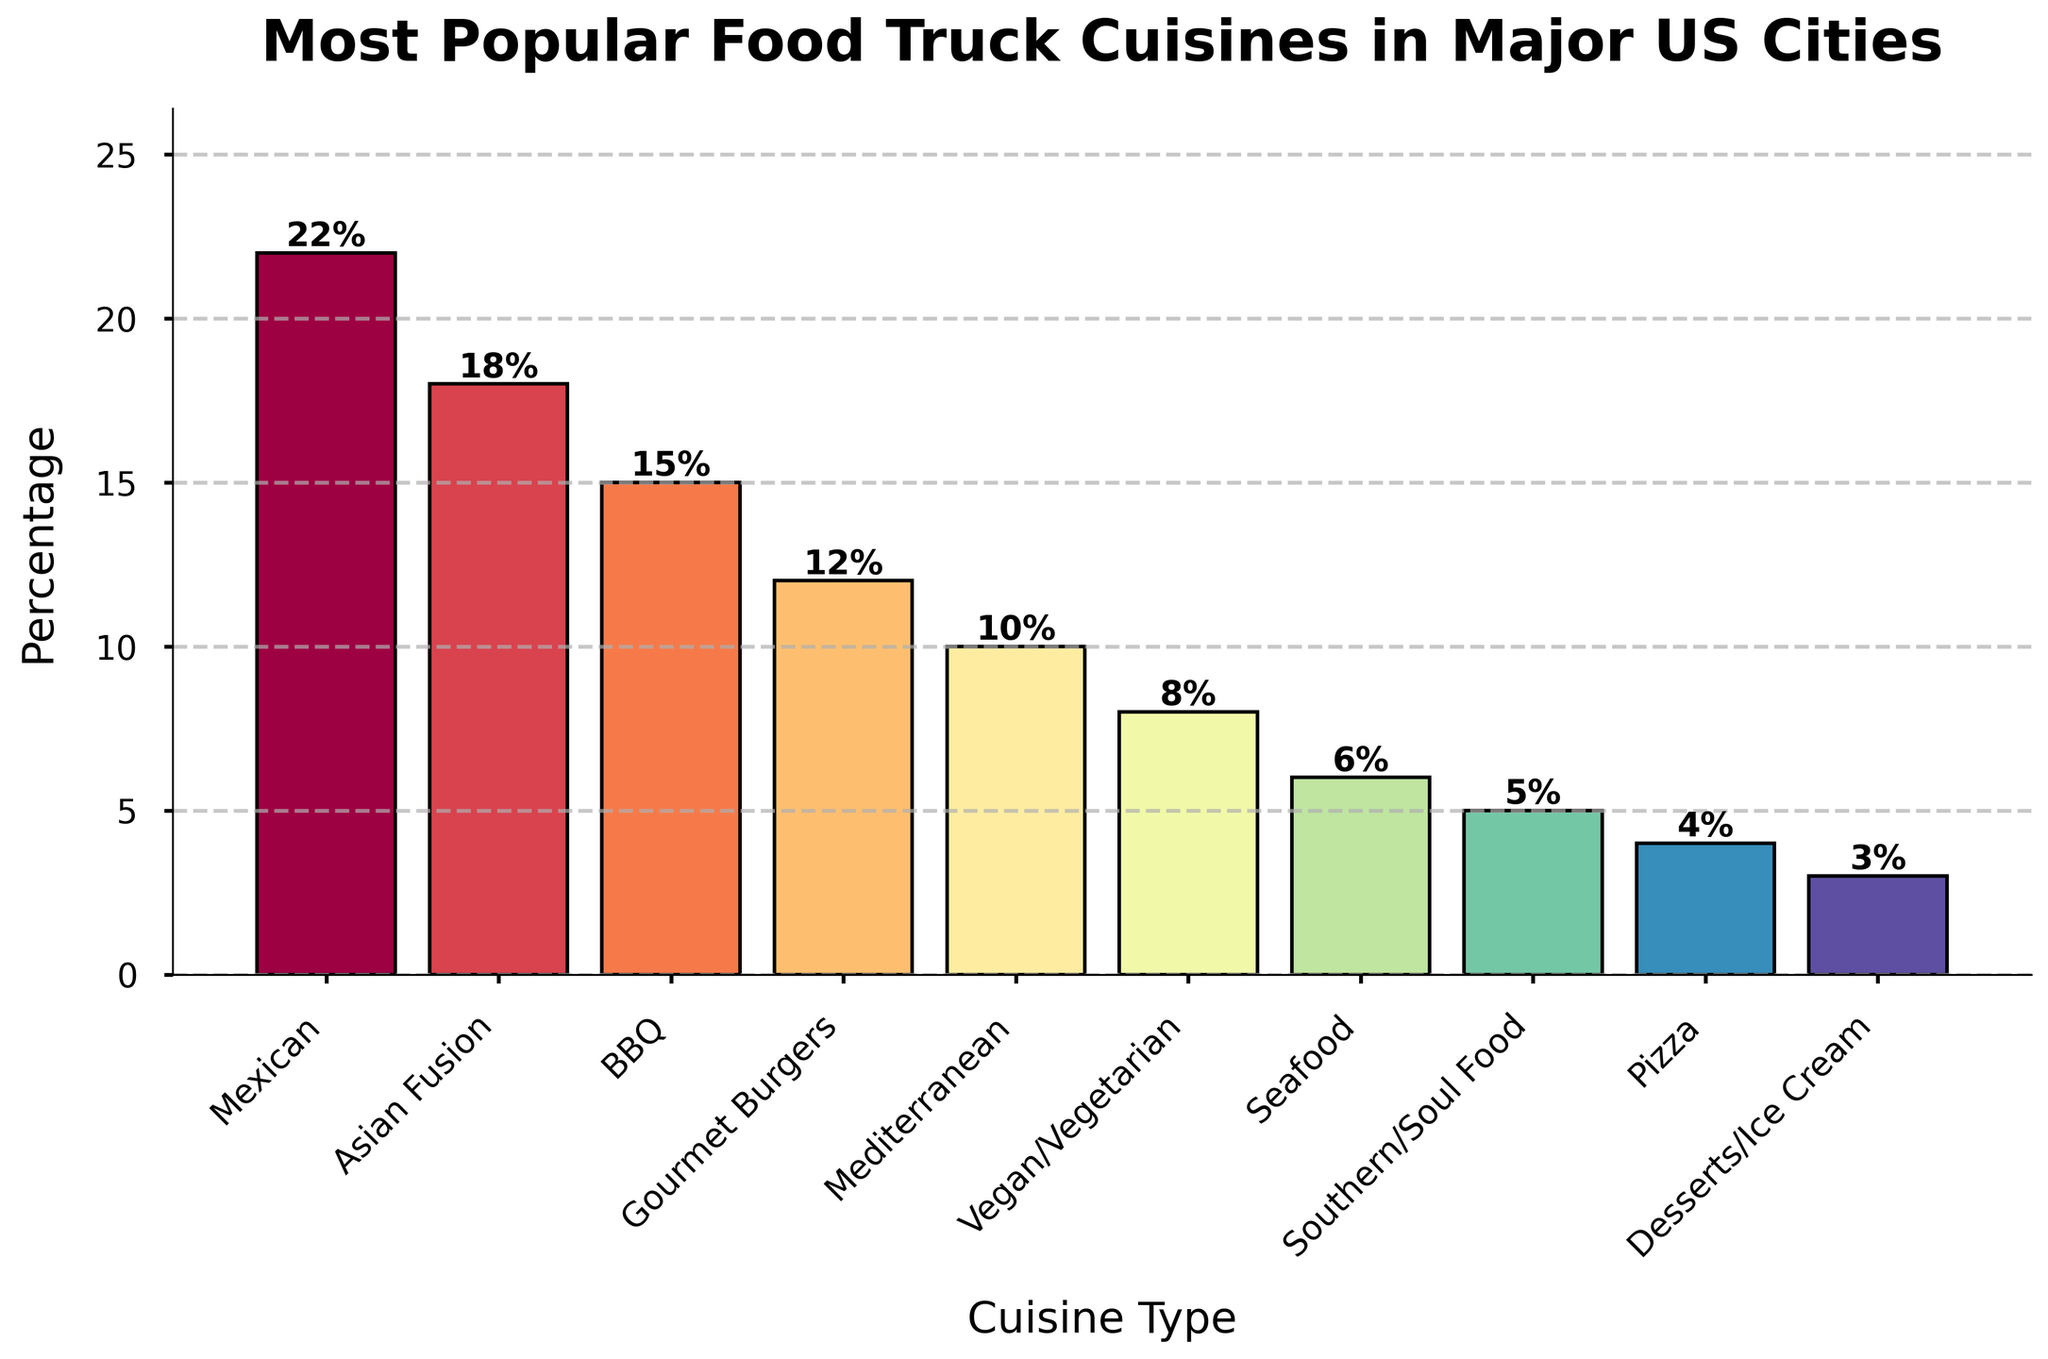Which cuisine has the highest popularity percentage? The tallest bar in the chart represents the cuisine with the highest percentage. The Mexican cuisine bar is the tallest at 22%.
Answer: Mexican Which cuisine has the lowest popularity percentage? The shortest bar in the chart represents the cuisine with the lowest percentage. The Desserts/Ice Cream cuisine bar is the shortest at 3%.
Answer: Desserts/Ice Cream How much more popular is Mexican cuisine compared to Asian Fusion cuisine? The Mexican cuisine bar is at 22%, and the Asian Fusion cuisine bar is at 18%. Subtract the Asian Fusion percentage from the Mexican percentage (22% - 18%).
Answer: 4% Which cuisines have a percentage greater than 15%? By examining the heights of the bars, we find that the cuisines with percentages greater than 15% are Mexican (22%), Asian Fusion (18%), and BBQ (15%).
Answer: Mexican, Asian Fusion What is the combined percentage of Vegan/Vegetarian and Seafood cuisines? The percentages for Vegan/Vegetarian and Seafood are 8% and 6%, respectively. Adding these together results in 8% + 6%.
Answer: 14% Which cuisine is more popular, Mediterranean or Gourmet Burgers, and by how much? The Mediterranean cuisine bar has a percentage of 10%, while the Gourmet Burgers bar has 12%. Subtract the Mediterranean percentage from the Gourmet Burgers percentage (12% - 10%).
Answer: Gourmet Burgers by 2% What is the average popularity percentage of the top three cuisines? The top three cuisines are Mexican (22%), Asian Fusion (18%), and BBQ (15%). Calculate the average by adding these percentages and dividing by three: (22 + 18 + 15) / 3.
Answer: 18.33% Between Mediterranean and Southern/Soul Food, which has a wider color spectrum and which has a narrower? Visually identify the bars' colors for Mediterranean (10%) and Southern/Soul Food (5%). Mediterranean is represented by a more central and vivid color, while Southern/Soul Food has a more muted spectrum.
Answer: Mediterranean (wider), Southern/Soul Food (narrower) How many cuisines have percentages less than or equal to 10%? By observing the bars, we see that Mediterranean (10%), Vegan/Vegetarian (8%), Seafood (6%), Southern/Soul Food (5%), Pizza (4%), and Desserts/Ice Cream (3%) all have percentages ≤ 10%. Count these cuisines (6 in total).
Answer: 6 Which cuisine type has a higher percentage: BBQ or Seafood, and by how much? The BBQ percentage is 15%, and the Seafood percentage is 6%. Subtract the Seafood percentage from the BBQ percentage (15% - 6%).
Answer: BBQ by 9% 